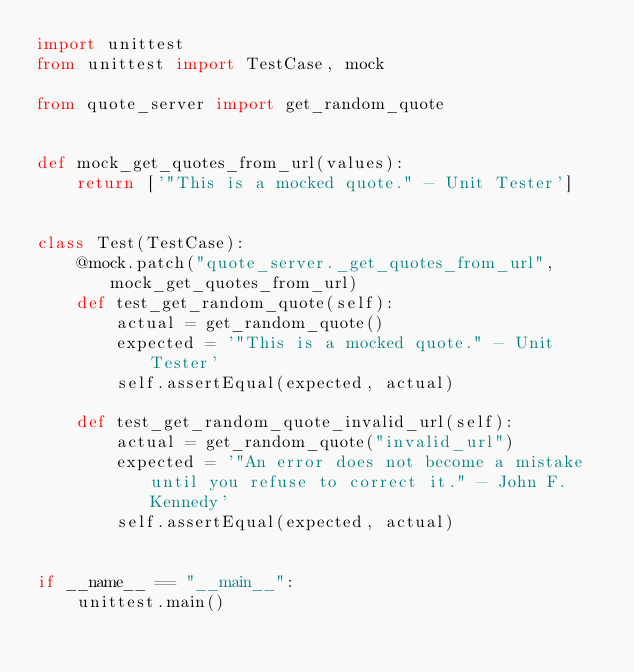<code> <loc_0><loc_0><loc_500><loc_500><_Python_>import unittest
from unittest import TestCase, mock

from quote_server import get_random_quote


def mock_get_quotes_from_url(values):
    return ['"This is a mocked quote." - Unit Tester']


class Test(TestCase):
    @mock.patch("quote_server._get_quotes_from_url", mock_get_quotes_from_url)
    def test_get_random_quote(self):
        actual = get_random_quote()
        expected = '"This is a mocked quote." - Unit Tester'
        self.assertEqual(expected, actual)

    def test_get_random_quote_invalid_url(self):
        actual = get_random_quote("invalid_url")
        expected = '"An error does not become a mistake until you refuse to correct it." - John F. Kennedy'
        self.assertEqual(expected, actual)


if __name__ == "__main__":
    unittest.main()
</code> 